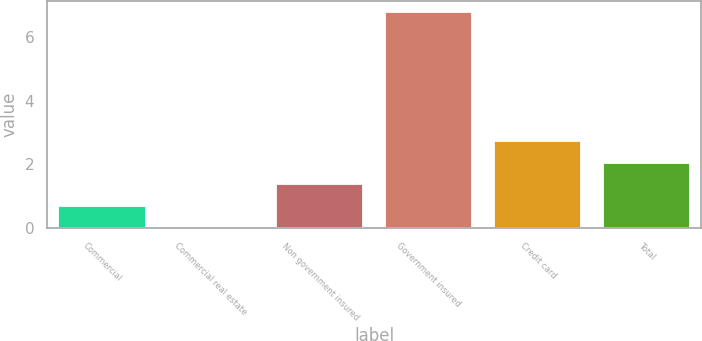Convert chart. <chart><loc_0><loc_0><loc_500><loc_500><bar_chart><fcel>Commercial<fcel>Commercial real estate<fcel>Non government insured<fcel>Government insured<fcel>Credit card<fcel>Total<nl><fcel>0.69<fcel>0.01<fcel>1.37<fcel>6.8<fcel>2.73<fcel>2.05<nl></chart> 